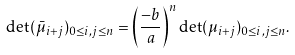<formula> <loc_0><loc_0><loc_500><loc_500>\det ( \bar { \mu } _ { i + j } ) _ { 0 \leq i , j \leq n } = \left ( \frac { - b } { a } \right ) ^ { n } \det ( \mu _ { i + j } ) _ { 0 \leq i , j \leq n } .</formula> 